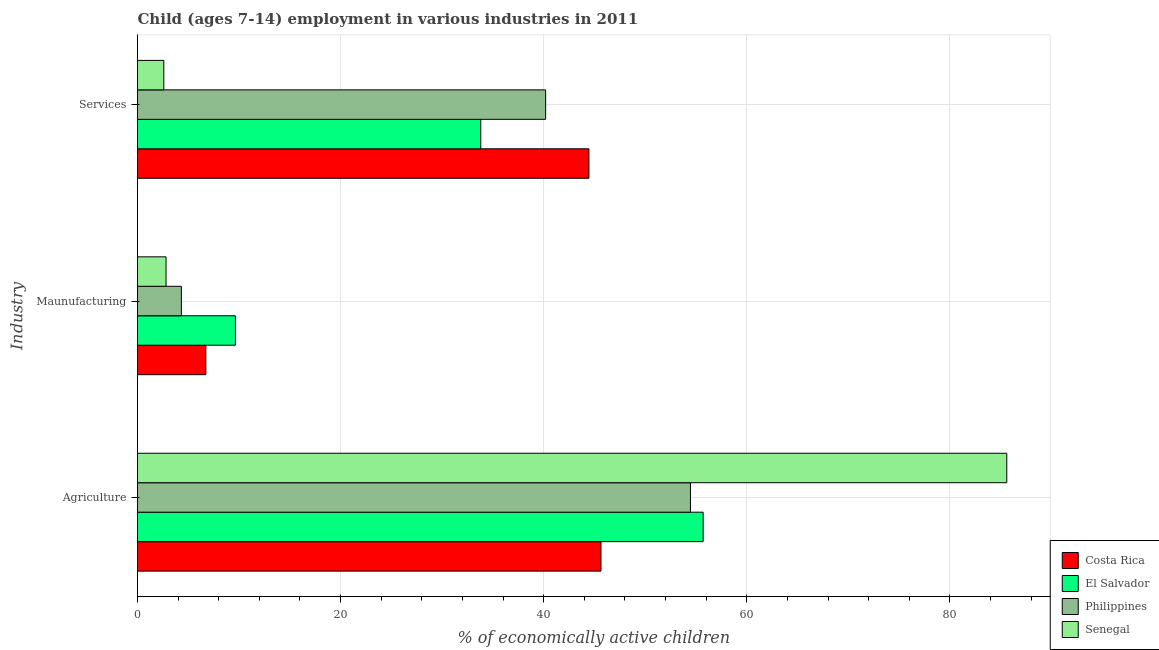Are the number of bars on each tick of the Y-axis equal?
Your answer should be compact. Yes. How many bars are there on the 2nd tick from the top?
Offer a very short reply. 4. How many bars are there on the 3rd tick from the bottom?
Ensure brevity in your answer.  4. What is the label of the 2nd group of bars from the top?
Ensure brevity in your answer.  Maunufacturing. What is the percentage of economically active children in services in Senegal?
Keep it short and to the point. 2.59. Across all countries, what is the maximum percentage of economically active children in services?
Offer a very short reply. 44.45. Across all countries, what is the minimum percentage of economically active children in services?
Your answer should be very brief. 2.59. In which country was the percentage of economically active children in agriculture maximum?
Your answer should be very brief. Senegal. What is the total percentage of economically active children in services in the graph?
Ensure brevity in your answer.  121.03. What is the difference between the percentage of economically active children in agriculture in Costa Rica and that in Senegal?
Your answer should be compact. -39.96. What is the difference between the percentage of economically active children in manufacturing in El Salvador and the percentage of economically active children in agriculture in Costa Rica?
Your response must be concise. -36. What is the average percentage of economically active children in services per country?
Give a very brief answer. 30.26. What is the difference between the percentage of economically active children in services and percentage of economically active children in manufacturing in Costa Rica?
Offer a very short reply. 37.72. What is the ratio of the percentage of economically active children in services in El Salvador to that in Costa Rica?
Your answer should be very brief. 0.76. Is the difference between the percentage of economically active children in services in Costa Rica and El Salvador greater than the difference between the percentage of economically active children in manufacturing in Costa Rica and El Salvador?
Give a very brief answer. Yes. What is the difference between the highest and the second highest percentage of economically active children in agriculture?
Provide a succinct answer. 29.9. What is the difference between the highest and the lowest percentage of economically active children in services?
Your answer should be compact. 41.86. Is the sum of the percentage of economically active children in services in El Salvador and Costa Rica greater than the maximum percentage of economically active children in agriculture across all countries?
Provide a succinct answer. No. What does the 3rd bar from the top in Services represents?
Keep it short and to the point. El Salvador. What does the 1st bar from the bottom in Maunufacturing represents?
Ensure brevity in your answer.  Costa Rica. Is it the case that in every country, the sum of the percentage of economically active children in agriculture and percentage of economically active children in manufacturing is greater than the percentage of economically active children in services?
Make the answer very short. Yes. Are the values on the major ticks of X-axis written in scientific E-notation?
Offer a very short reply. No. Does the graph contain grids?
Ensure brevity in your answer.  Yes. Where does the legend appear in the graph?
Provide a short and direct response. Bottom right. How are the legend labels stacked?
Make the answer very short. Vertical. What is the title of the graph?
Your answer should be compact. Child (ages 7-14) employment in various industries in 2011. What is the label or title of the X-axis?
Your response must be concise. % of economically active children. What is the label or title of the Y-axis?
Provide a short and direct response. Industry. What is the % of economically active children in Costa Rica in Agriculture?
Ensure brevity in your answer.  45.64. What is the % of economically active children of El Salvador in Agriculture?
Offer a very short reply. 55.7. What is the % of economically active children of Philippines in Agriculture?
Provide a succinct answer. 54.45. What is the % of economically active children of Senegal in Agriculture?
Keep it short and to the point. 85.6. What is the % of economically active children of Costa Rica in Maunufacturing?
Offer a terse response. 6.73. What is the % of economically active children in El Salvador in Maunufacturing?
Offer a very short reply. 9.64. What is the % of economically active children in Philippines in Maunufacturing?
Give a very brief answer. 4.32. What is the % of economically active children in Senegal in Maunufacturing?
Ensure brevity in your answer.  2.81. What is the % of economically active children in Costa Rica in Services?
Give a very brief answer. 44.45. What is the % of economically active children of El Salvador in Services?
Provide a succinct answer. 33.8. What is the % of economically active children of Philippines in Services?
Give a very brief answer. 40.19. What is the % of economically active children in Senegal in Services?
Offer a terse response. 2.59. Across all Industry, what is the maximum % of economically active children in Costa Rica?
Offer a terse response. 45.64. Across all Industry, what is the maximum % of economically active children of El Salvador?
Keep it short and to the point. 55.7. Across all Industry, what is the maximum % of economically active children in Philippines?
Offer a very short reply. 54.45. Across all Industry, what is the maximum % of economically active children in Senegal?
Give a very brief answer. 85.6. Across all Industry, what is the minimum % of economically active children in Costa Rica?
Your answer should be compact. 6.73. Across all Industry, what is the minimum % of economically active children of El Salvador?
Give a very brief answer. 9.64. Across all Industry, what is the minimum % of economically active children in Philippines?
Ensure brevity in your answer.  4.32. Across all Industry, what is the minimum % of economically active children in Senegal?
Offer a terse response. 2.59. What is the total % of economically active children of Costa Rica in the graph?
Offer a terse response. 96.82. What is the total % of economically active children in El Salvador in the graph?
Provide a succinct answer. 99.14. What is the total % of economically active children of Philippines in the graph?
Ensure brevity in your answer.  98.96. What is the total % of economically active children of Senegal in the graph?
Your answer should be compact. 91. What is the difference between the % of economically active children of Costa Rica in Agriculture and that in Maunufacturing?
Offer a terse response. 38.91. What is the difference between the % of economically active children of El Salvador in Agriculture and that in Maunufacturing?
Give a very brief answer. 46.06. What is the difference between the % of economically active children in Philippines in Agriculture and that in Maunufacturing?
Make the answer very short. 50.13. What is the difference between the % of economically active children of Senegal in Agriculture and that in Maunufacturing?
Offer a very short reply. 82.79. What is the difference between the % of economically active children of Costa Rica in Agriculture and that in Services?
Make the answer very short. 1.19. What is the difference between the % of economically active children in El Salvador in Agriculture and that in Services?
Your answer should be very brief. 21.9. What is the difference between the % of economically active children in Philippines in Agriculture and that in Services?
Keep it short and to the point. 14.26. What is the difference between the % of economically active children of Senegal in Agriculture and that in Services?
Make the answer very short. 83.01. What is the difference between the % of economically active children of Costa Rica in Maunufacturing and that in Services?
Offer a very short reply. -37.72. What is the difference between the % of economically active children in El Salvador in Maunufacturing and that in Services?
Offer a very short reply. -24.16. What is the difference between the % of economically active children in Philippines in Maunufacturing and that in Services?
Provide a succinct answer. -35.87. What is the difference between the % of economically active children in Senegal in Maunufacturing and that in Services?
Offer a terse response. 0.22. What is the difference between the % of economically active children of Costa Rica in Agriculture and the % of economically active children of Philippines in Maunufacturing?
Your answer should be very brief. 41.32. What is the difference between the % of economically active children in Costa Rica in Agriculture and the % of economically active children in Senegal in Maunufacturing?
Provide a short and direct response. 42.83. What is the difference between the % of economically active children of El Salvador in Agriculture and the % of economically active children of Philippines in Maunufacturing?
Give a very brief answer. 51.38. What is the difference between the % of economically active children of El Salvador in Agriculture and the % of economically active children of Senegal in Maunufacturing?
Keep it short and to the point. 52.89. What is the difference between the % of economically active children in Philippines in Agriculture and the % of economically active children in Senegal in Maunufacturing?
Keep it short and to the point. 51.64. What is the difference between the % of economically active children in Costa Rica in Agriculture and the % of economically active children in El Salvador in Services?
Make the answer very short. 11.84. What is the difference between the % of economically active children in Costa Rica in Agriculture and the % of economically active children in Philippines in Services?
Make the answer very short. 5.45. What is the difference between the % of economically active children of Costa Rica in Agriculture and the % of economically active children of Senegal in Services?
Your answer should be compact. 43.05. What is the difference between the % of economically active children in El Salvador in Agriculture and the % of economically active children in Philippines in Services?
Give a very brief answer. 15.51. What is the difference between the % of economically active children in El Salvador in Agriculture and the % of economically active children in Senegal in Services?
Offer a very short reply. 53.11. What is the difference between the % of economically active children of Philippines in Agriculture and the % of economically active children of Senegal in Services?
Your answer should be compact. 51.86. What is the difference between the % of economically active children in Costa Rica in Maunufacturing and the % of economically active children in El Salvador in Services?
Your answer should be compact. -27.07. What is the difference between the % of economically active children of Costa Rica in Maunufacturing and the % of economically active children of Philippines in Services?
Provide a short and direct response. -33.46. What is the difference between the % of economically active children in Costa Rica in Maunufacturing and the % of economically active children in Senegal in Services?
Make the answer very short. 4.14. What is the difference between the % of economically active children of El Salvador in Maunufacturing and the % of economically active children of Philippines in Services?
Offer a very short reply. -30.55. What is the difference between the % of economically active children of El Salvador in Maunufacturing and the % of economically active children of Senegal in Services?
Your response must be concise. 7.05. What is the difference between the % of economically active children in Philippines in Maunufacturing and the % of economically active children in Senegal in Services?
Make the answer very short. 1.73. What is the average % of economically active children of Costa Rica per Industry?
Give a very brief answer. 32.27. What is the average % of economically active children in El Salvador per Industry?
Ensure brevity in your answer.  33.05. What is the average % of economically active children in Philippines per Industry?
Your response must be concise. 32.99. What is the average % of economically active children of Senegal per Industry?
Ensure brevity in your answer.  30.33. What is the difference between the % of economically active children of Costa Rica and % of economically active children of El Salvador in Agriculture?
Give a very brief answer. -10.06. What is the difference between the % of economically active children in Costa Rica and % of economically active children in Philippines in Agriculture?
Ensure brevity in your answer.  -8.81. What is the difference between the % of economically active children of Costa Rica and % of economically active children of Senegal in Agriculture?
Keep it short and to the point. -39.96. What is the difference between the % of economically active children in El Salvador and % of economically active children in Senegal in Agriculture?
Your response must be concise. -29.9. What is the difference between the % of economically active children of Philippines and % of economically active children of Senegal in Agriculture?
Your response must be concise. -31.15. What is the difference between the % of economically active children of Costa Rica and % of economically active children of El Salvador in Maunufacturing?
Ensure brevity in your answer.  -2.91. What is the difference between the % of economically active children in Costa Rica and % of economically active children in Philippines in Maunufacturing?
Provide a succinct answer. 2.41. What is the difference between the % of economically active children of Costa Rica and % of economically active children of Senegal in Maunufacturing?
Make the answer very short. 3.92. What is the difference between the % of economically active children in El Salvador and % of economically active children in Philippines in Maunufacturing?
Make the answer very short. 5.32. What is the difference between the % of economically active children of El Salvador and % of economically active children of Senegal in Maunufacturing?
Your response must be concise. 6.83. What is the difference between the % of economically active children of Philippines and % of economically active children of Senegal in Maunufacturing?
Offer a very short reply. 1.51. What is the difference between the % of economically active children of Costa Rica and % of economically active children of El Salvador in Services?
Your response must be concise. 10.65. What is the difference between the % of economically active children in Costa Rica and % of economically active children in Philippines in Services?
Make the answer very short. 4.26. What is the difference between the % of economically active children of Costa Rica and % of economically active children of Senegal in Services?
Offer a very short reply. 41.86. What is the difference between the % of economically active children in El Salvador and % of economically active children in Philippines in Services?
Offer a very short reply. -6.39. What is the difference between the % of economically active children in El Salvador and % of economically active children in Senegal in Services?
Provide a short and direct response. 31.21. What is the difference between the % of economically active children in Philippines and % of economically active children in Senegal in Services?
Your response must be concise. 37.6. What is the ratio of the % of economically active children of Costa Rica in Agriculture to that in Maunufacturing?
Offer a terse response. 6.78. What is the ratio of the % of economically active children of El Salvador in Agriculture to that in Maunufacturing?
Your answer should be very brief. 5.78. What is the ratio of the % of economically active children in Philippines in Agriculture to that in Maunufacturing?
Give a very brief answer. 12.6. What is the ratio of the % of economically active children of Senegal in Agriculture to that in Maunufacturing?
Give a very brief answer. 30.46. What is the ratio of the % of economically active children in Costa Rica in Agriculture to that in Services?
Keep it short and to the point. 1.03. What is the ratio of the % of economically active children of El Salvador in Agriculture to that in Services?
Keep it short and to the point. 1.65. What is the ratio of the % of economically active children of Philippines in Agriculture to that in Services?
Your answer should be compact. 1.35. What is the ratio of the % of economically active children in Senegal in Agriculture to that in Services?
Keep it short and to the point. 33.05. What is the ratio of the % of economically active children of Costa Rica in Maunufacturing to that in Services?
Your response must be concise. 0.15. What is the ratio of the % of economically active children in El Salvador in Maunufacturing to that in Services?
Provide a succinct answer. 0.29. What is the ratio of the % of economically active children in Philippines in Maunufacturing to that in Services?
Offer a terse response. 0.11. What is the ratio of the % of economically active children of Senegal in Maunufacturing to that in Services?
Offer a terse response. 1.08. What is the difference between the highest and the second highest % of economically active children of Costa Rica?
Your answer should be compact. 1.19. What is the difference between the highest and the second highest % of economically active children of El Salvador?
Offer a terse response. 21.9. What is the difference between the highest and the second highest % of economically active children of Philippines?
Provide a short and direct response. 14.26. What is the difference between the highest and the second highest % of economically active children in Senegal?
Offer a very short reply. 82.79. What is the difference between the highest and the lowest % of economically active children in Costa Rica?
Provide a succinct answer. 38.91. What is the difference between the highest and the lowest % of economically active children of El Salvador?
Offer a very short reply. 46.06. What is the difference between the highest and the lowest % of economically active children of Philippines?
Offer a very short reply. 50.13. What is the difference between the highest and the lowest % of economically active children of Senegal?
Your response must be concise. 83.01. 